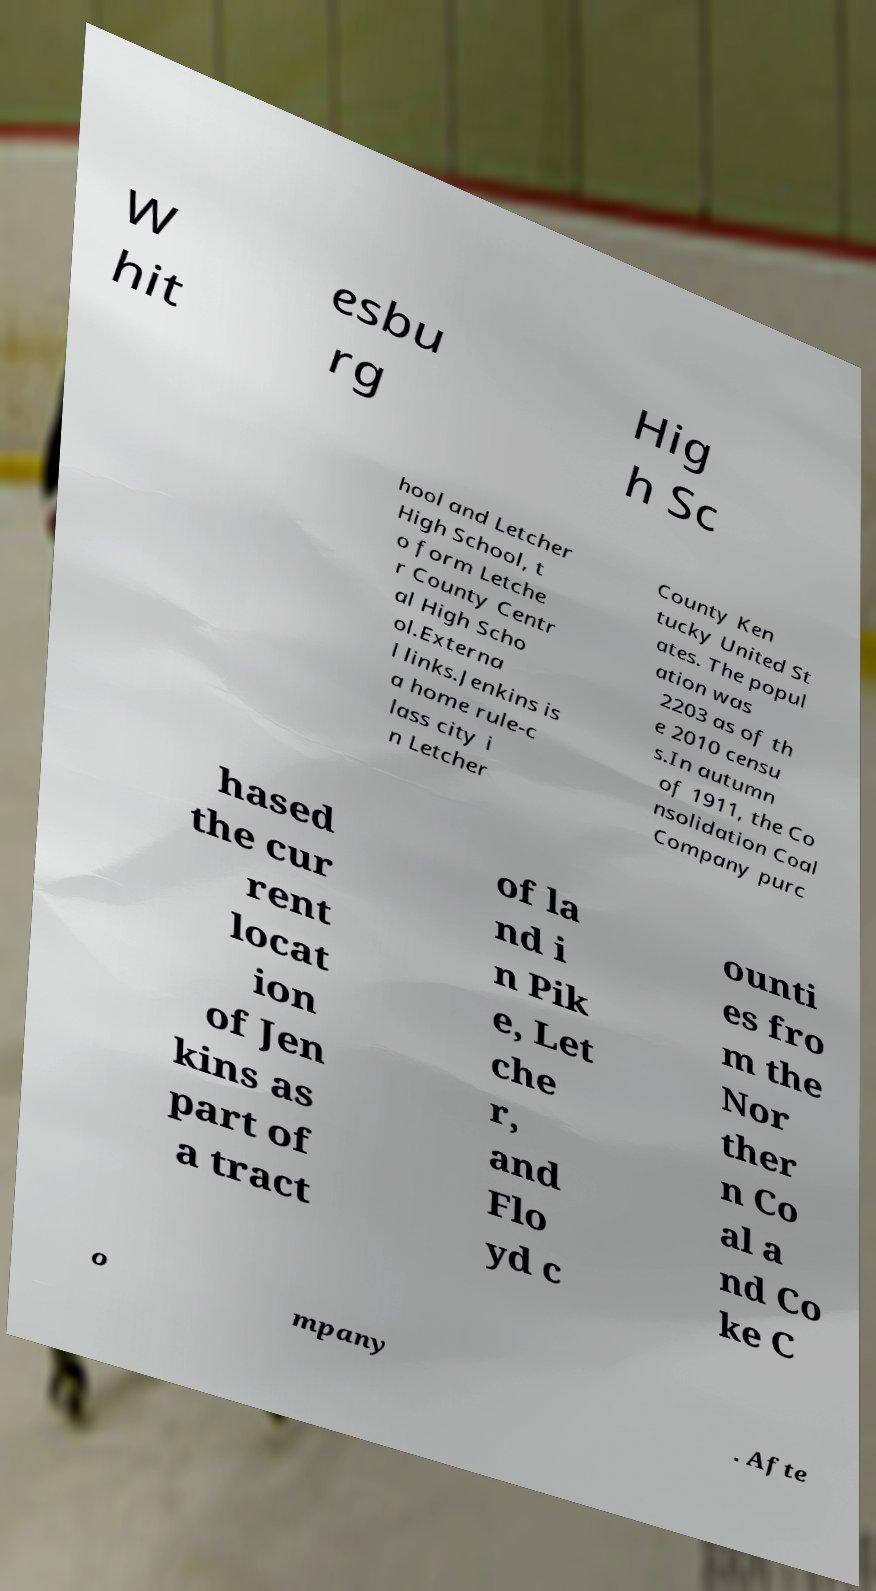Could you assist in decoding the text presented in this image and type it out clearly? W hit esbu rg Hig h Sc hool and Letcher High School, t o form Letche r County Centr al High Scho ol.Externa l links.Jenkins is a home rule-c lass city i n Letcher County Ken tucky United St ates. The popul ation was 2203 as of th e 2010 censu s.In autumn of 1911, the Co nsolidation Coal Company purc hased the cur rent locat ion of Jen kins as part of a tract of la nd i n Pik e, Let che r, and Flo yd c ounti es fro m the Nor ther n Co al a nd Co ke C o mpany . Afte 